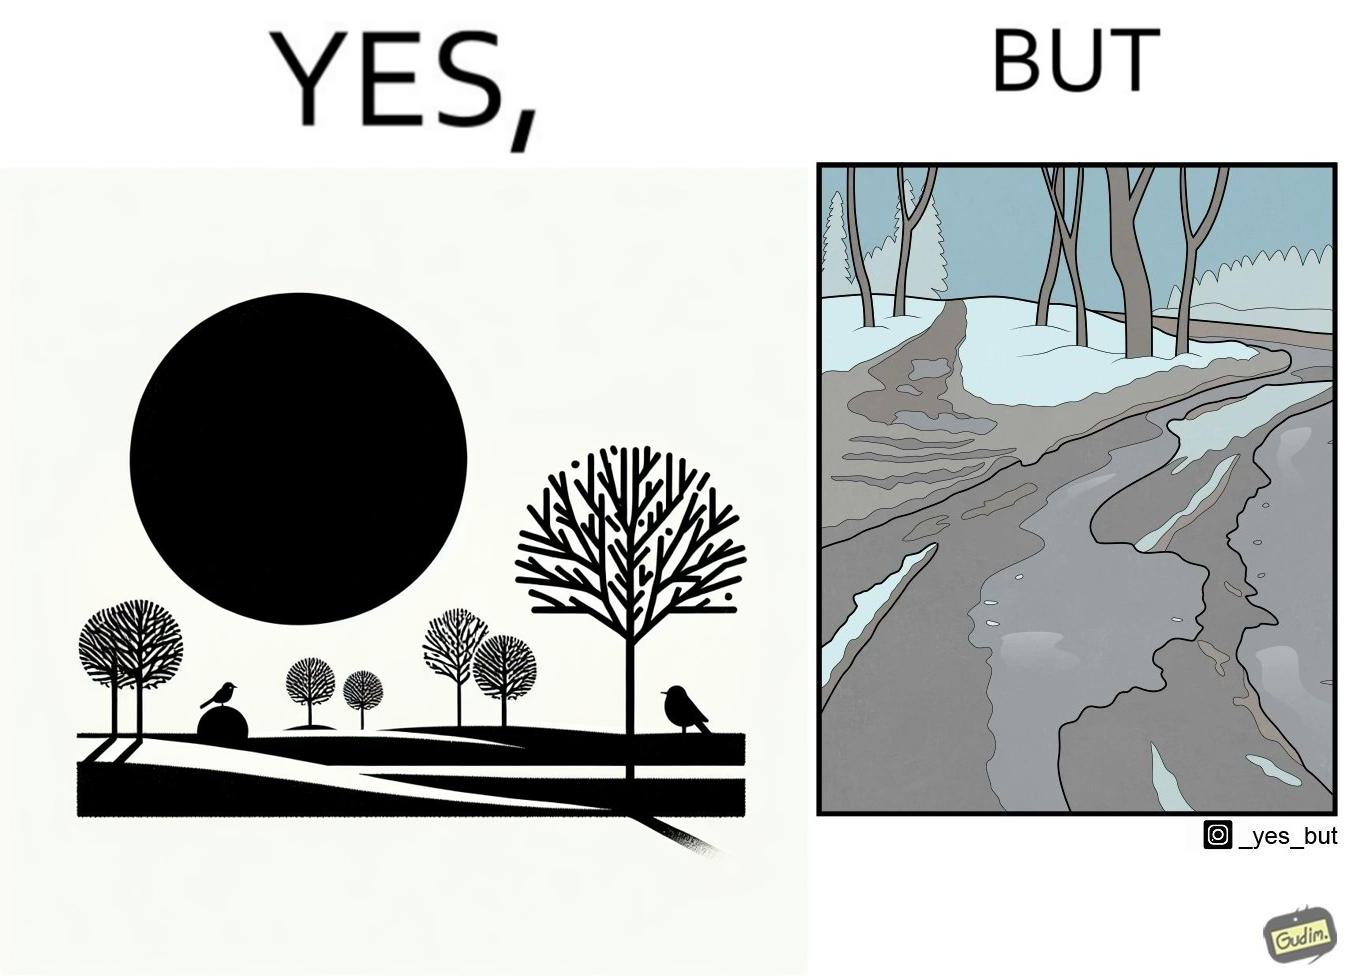Does this image contain satire or humor? Yes, this image is satirical. 